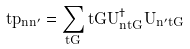Convert formula to latex. <formula><loc_0><loc_0><loc_500><loc_500>\vec { t } { p } _ { n n ^ { \prime } } = \sum _ { \vec { t } { G } } \vec { t } { G } U _ { n \vec { t } { G } } ^ { \dag } U _ { n ^ { \prime } \vec { t } { G } }</formula> 